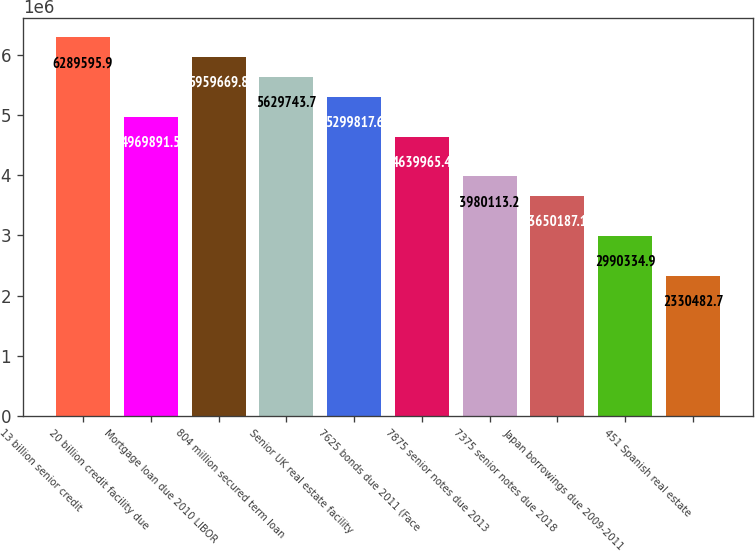<chart> <loc_0><loc_0><loc_500><loc_500><bar_chart><fcel>13 billion senior credit<fcel>20 billion credit facility due<fcel>Mortgage loan due 2010 LIBOR<fcel>804 million secured term loan<fcel>Senior UK real estate facility<fcel>7625 bonds due 2011 (Face<fcel>7875 senior notes due 2013<fcel>7375 senior notes due 2018<fcel>Japan borrowings due 2009-2011<fcel>451 Spanish real estate<nl><fcel>6.2896e+06<fcel>4.96989e+06<fcel>5.95967e+06<fcel>5.62974e+06<fcel>5.29982e+06<fcel>4.63997e+06<fcel>3.98011e+06<fcel>3.65019e+06<fcel>2.99033e+06<fcel>2.33048e+06<nl></chart> 